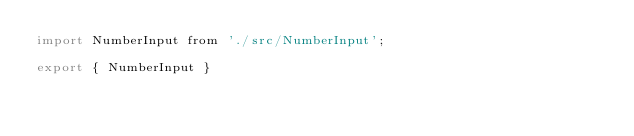<code> <loc_0><loc_0><loc_500><loc_500><_JavaScript_>import NumberInput from './src/NumberInput';

export { NumberInput }</code> 